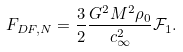<formula> <loc_0><loc_0><loc_500><loc_500>F _ { D F , N } = \frac { 3 } { 2 } \frac { G ^ { 2 } M ^ { 2 } \rho _ { 0 } } { c _ { \infty } ^ { 2 } } { \mathcal { F } } _ { 1 } .</formula> 